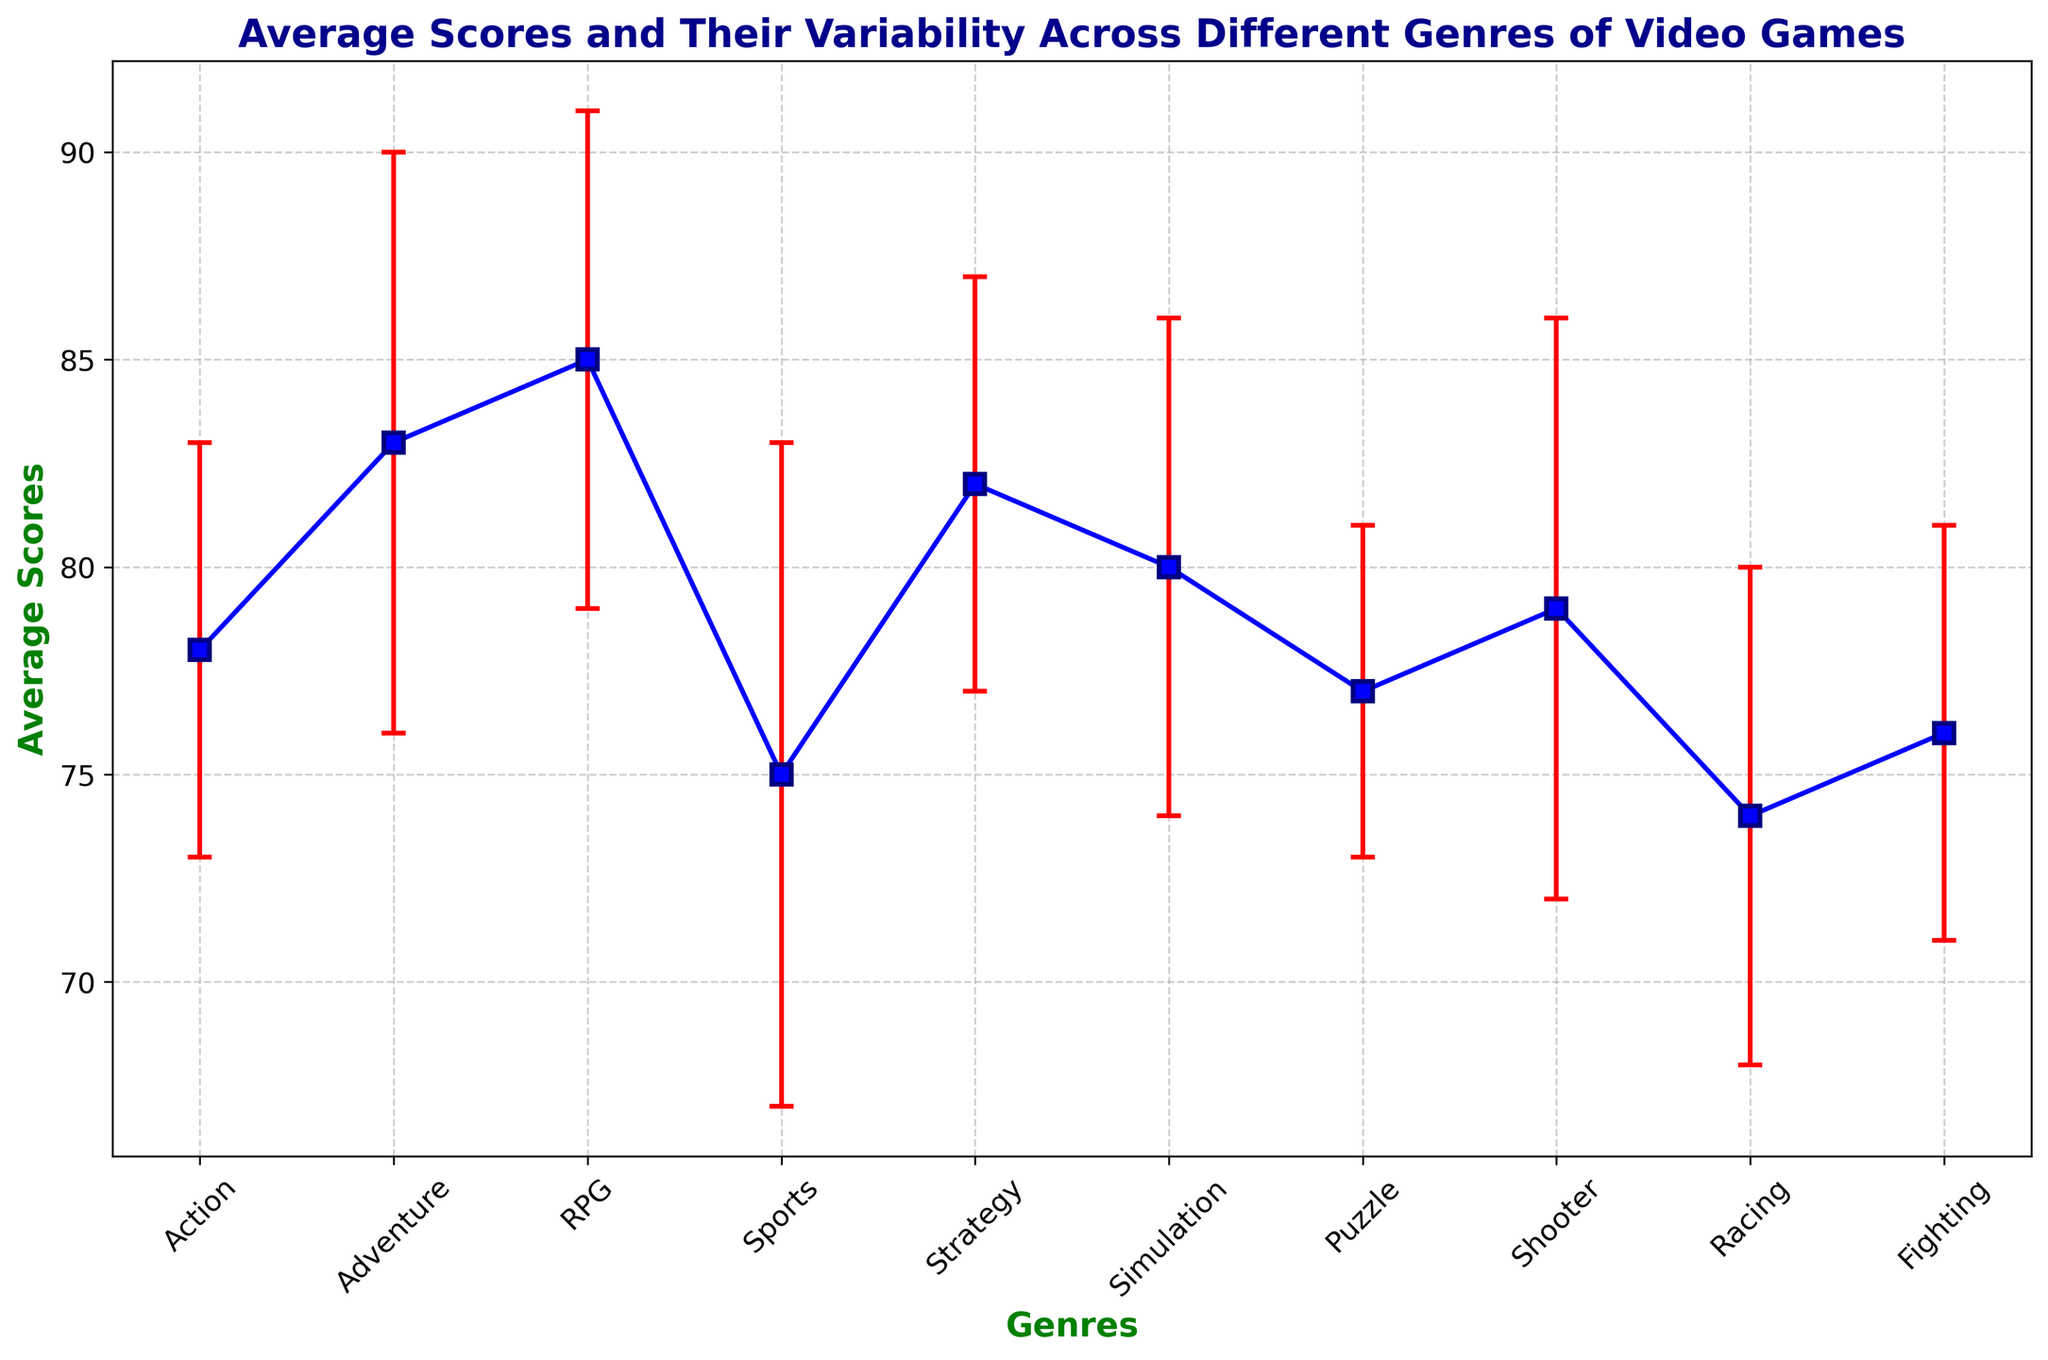Which genre has the highest average score? By looking at the plot, we can see which datapoint in the y-axis is the highest. RPG has the highest average score.
Answer: RPG Which genre has the biggest variability in scores? We need to identify which genre has the largest error bar as it signifies the standard deviation. Sports has the biggest variability since its error bar (red) is the longest.
Answer: Sports Which genres have average scores greater than 80? We need to check the y-axis values and see which genres exceed the 80 mark. Adventure, RPG, Strategy, and Simulation have average scores greater than 80.
Answer: Adventure, RPG, Strategy, Simulation What's the difference in average scores between Racing and Adventure? We find the average scores of Racing and Adventure from the plot and subtract the Racing's score from Adventure's. Adventure's score is 83, and Racing's score is 74, so the difference is 83 - 74.
Answer: 9 Which genres have similar average scores but different variabilities? Find genres with close average scores but different error bar lengths. Shooter (79) and RPG (78) have similar averages, but Shooter has a longer error bar (more variability).
Answer: Shooter and RPG What is the mean of the average scores of Simulation, Shooter, and Fighting? First, add the average scores of these genres, then divide by the number of genres. Simulation: 80, Shooter: 79, Fighting: 76. Calculation: (80 + 79 + 76) / 3.
Answer: 78.33 Which genre has the smallest variability in scores? We check the smallest error bar length in the plot which indicates the smallest standard deviation. Puzzle has the smallest variability.
Answer: Puzzle What's the combined average score of Adventure, Simulation, and Puzzle? Add their average scores: Adventure (83), Simulation (80), and Puzzle (77). Then carry out the sums: 83 + 80 + 77.
Answer: 240 